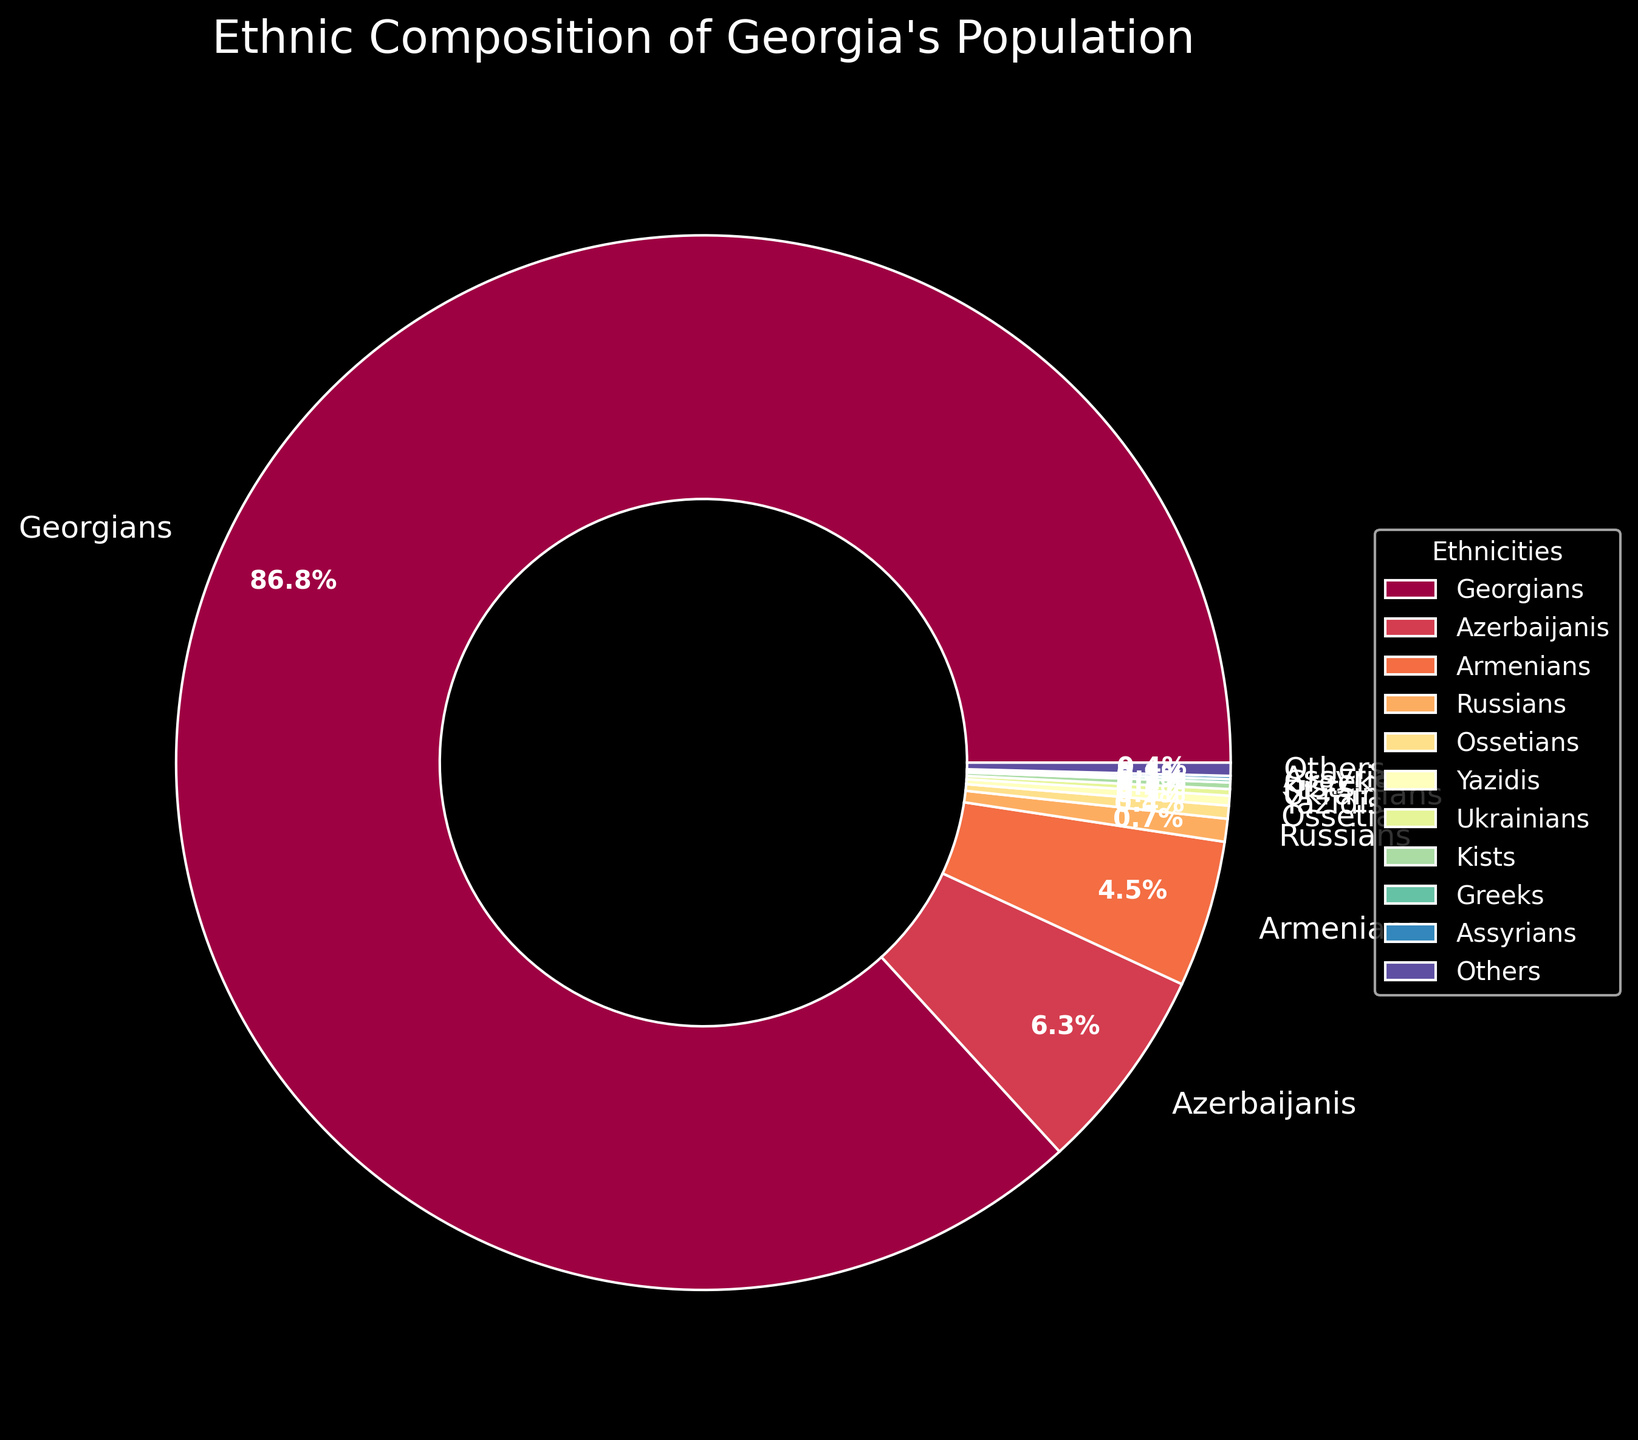Which ethnicity constitutes the majority of Georgia's population? The largest section in the pie chart is labeled "Georgians" with a percentage of 86.8%, indicating the majority.
Answer: Georgians How much more percentage do Georgians represent compared to Azerbaijanis? Subtract the percentage of Azerbaijanis (6.3%) from that of Georgians (86.8%): 86.8% - 6.3% = 80.5%.
Answer: 80.5% What is the combined percentage of Armenians and Russians? Add the percentages of Armenians (4.5%) and Russians (0.7%): 4.5% + 0.7% = 5.2%.
Answer: 5.2% Which group has a larger percentage, Ossetians or Yazidis? Comparing the two percentages, Ossetians have 0.4% while Yazidis have 0.3%. Therefore, Ossetians have a larger percentage.
Answer: Ossetians What is the smallest ethnic group by percentage, excluding the "Others" category? By comparing the percentages of the groups listed, the smallest group excluding "Others" (0.4%) is Greeks with 0.1%.
Answer: Greeks What is the combined total percentage of all ethnic minorities listed? Sum the percentages of all ethnic groups except Georgians: 6.3% + 4.5% + 0.7% + 0.4% + 0.3% + 0.2% + 0.2% + 0.1% + 0.1% + 0.4% = 13.2%.
Answer: 13.2% How many ethnicities are shown in the figure? Count the number of labeled wedges in the pie chart which corresponds to the number of ethnic groups: Georgians, Azerbaijanis, Armenians, Russians, Ossetians, Yazidis, Ukrainians, Kists, Greeks, Assyrians, and Others. The total is 11.
Answer: 11 Which ethnic group has a color in the blue spectrum in the pie chart? Identifying colors visually, one of the groups (e.g., "Georgians" in the depiction) will be shaded with a blue hue from the Spectral color scheme.
Answer: (Depends on the color scheme assignment, answer will vary) 